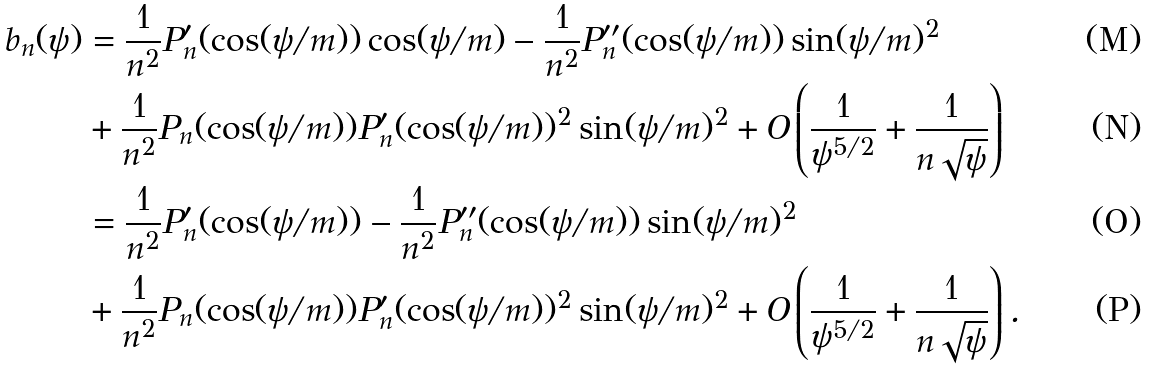Convert formula to latex. <formula><loc_0><loc_0><loc_500><loc_500>b _ { n } ( \psi ) & = \frac { 1 } { n ^ { 2 } } P _ { n } ^ { \prime } ( \cos ( \psi / m ) ) \cos ( \psi / m ) - \frac { 1 } { n ^ { 2 } } P _ { n } ^ { \prime \prime } ( \cos ( \psi / m ) ) \sin ( \psi / m ) ^ { 2 } \\ & + \frac { 1 } { n ^ { 2 } } P _ { n } ( \cos ( \psi / m ) ) P _ { n } ^ { \prime } ( \cos ( \psi / m ) ) ^ { 2 } \sin ( \psi / m ) ^ { 2 } + O \left ( \frac { 1 } { \psi ^ { 5 / 2 } } + \frac { 1 } { n \sqrt { \psi } } \right ) \\ & = \frac { 1 } { n ^ { 2 } } P _ { n } ^ { \prime } ( \cos ( \psi / m ) ) - \frac { 1 } { n ^ { 2 } } P _ { n } ^ { \prime \prime } ( \cos ( \psi / m ) ) \sin ( \psi / m ) ^ { 2 } \\ & + \frac { 1 } { n ^ { 2 } } P _ { n } ( \cos ( \psi / m ) ) P _ { n } ^ { \prime } ( \cos ( \psi / m ) ) ^ { 2 } \sin ( \psi / m ) ^ { 2 } + O \left ( \frac { 1 } { \psi ^ { 5 / 2 } } + \frac { 1 } { n \sqrt { \psi } } \right ) .</formula> 